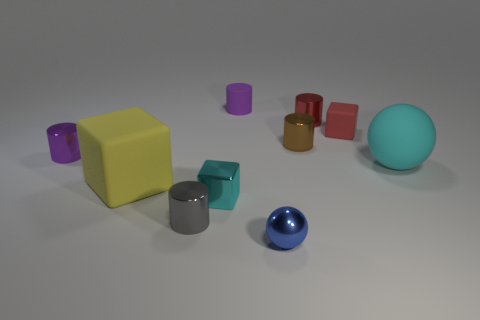There is a tiny matte thing to the right of the small red shiny cylinder; does it have the same color as the tiny metallic thing behind the red rubber block?
Ensure brevity in your answer.  Yes. What shape is the rubber thing that is behind the tiny brown thing and right of the tiny brown cylinder?
Provide a short and direct response. Cube. What is the color of the large rubber thing that is on the left side of the big thing to the right of the small metallic cylinder on the right side of the brown object?
Your response must be concise. Yellow. Is the number of red metal cylinders that are to the left of the small brown thing less than the number of green cylinders?
Your response must be concise. No. There is a small rubber thing that is to the right of the tiny brown cylinder; is it the same shape as the large thing to the left of the tiny blue metal object?
Make the answer very short. Yes. How many objects are either small shiny cylinders that are right of the small purple metallic cylinder or small gray objects?
Ensure brevity in your answer.  3. There is a object that is the same color as the metal cube; what is its material?
Your answer should be very brief. Rubber. Is there a small metallic cylinder that is right of the purple object left of the small block that is in front of the large cyan rubber sphere?
Provide a short and direct response. Yes. Is the number of cylinders behind the tiny cyan shiny object less than the number of gray objects that are on the right side of the tiny brown metal cylinder?
Ensure brevity in your answer.  No. What is the color of the ball that is the same material as the tiny red cylinder?
Your answer should be very brief. Blue. 